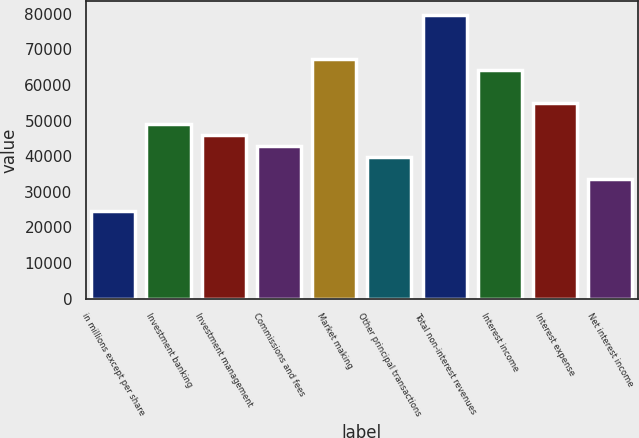Convert chart to OTSL. <chart><loc_0><loc_0><loc_500><loc_500><bar_chart><fcel>in millions except per share<fcel>Investment banking<fcel>Investment management<fcel>Commissions and fees<fcel>Market making<fcel>Other principal transactions<fcel>Total non-interest revenues<fcel>Interest income<fcel>Interest expense<fcel>Net interest income<nl><fcel>24489.7<fcel>48963<fcel>45903.8<fcel>42844.7<fcel>67318<fcel>39785.5<fcel>79554.7<fcel>64258.9<fcel>55081.3<fcel>33667.2<nl></chart> 